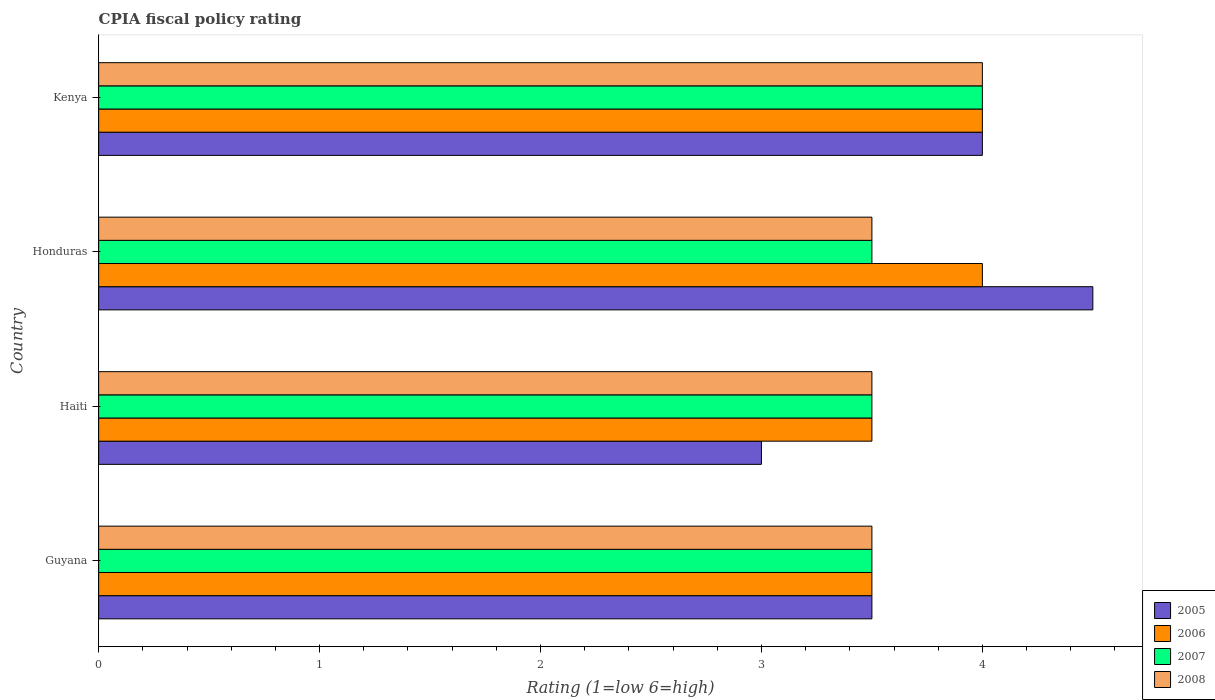How many different coloured bars are there?
Keep it short and to the point. 4. How many groups of bars are there?
Give a very brief answer. 4. Are the number of bars on each tick of the Y-axis equal?
Offer a very short reply. Yes. How many bars are there on the 3rd tick from the bottom?
Provide a succinct answer. 4. What is the label of the 4th group of bars from the top?
Provide a short and direct response. Guyana. In how many cases, is the number of bars for a given country not equal to the number of legend labels?
Provide a short and direct response. 0. What is the CPIA rating in 2008 in Kenya?
Your response must be concise. 4. In which country was the CPIA rating in 2007 maximum?
Make the answer very short. Kenya. In which country was the CPIA rating in 2005 minimum?
Provide a succinct answer. Haiti. What is the difference between the CPIA rating in 2005 in Guyana and that in Haiti?
Your answer should be very brief. 0.5. What is the average CPIA rating in 2008 per country?
Keep it short and to the point. 3.62. What is the difference between the CPIA rating in 2008 and CPIA rating in 2006 in Guyana?
Provide a succinct answer. 0. In how many countries, is the CPIA rating in 2008 greater than 2.4 ?
Give a very brief answer. 4. What is the difference between the highest and the second highest CPIA rating in 2008?
Provide a succinct answer. 0.5. What is the difference between the highest and the lowest CPIA rating in 2005?
Give a very brief answer. 1.5. In how many countries, is the CPIA rating in 2007 greater than the average CPIA rating in 2007 taken over all countries?
Your answer should be very brief. 1. What does the 2nd bar from the top in Haiti represents?
Offer a very short reply. 2007. Is it the case that in every country, the sum of the CPIA rating in 2006 and CPIA rating in 2007 is greater than the CPIA rating in 2005?
Provide a short and direct response. Yes. How many bars are there?
Ensure brevity in your answer.  16. What is the difference between two consecutive major ticks on the X-axis?
Offer a very short reply. 1. Does the graph contain any zero values?
Your answer should be compact. No. Where does the legend appear in the graph?
Provide a succinct answer. Bottom right. How are the legend labels stacked?
Provide a succinct answer. Vertical. What is the title of the graph?
Offer a very short reply. CPIA fiscal policy rating. What is the label or title of the X-axis?
Give a very brief answer. Rating (1=low 6=high). What is the Rating (1=low 6=high) in 2005 in Guyana?
Your answer should be compact. 3.5. What is the Rating (1=low 6=high) in 2006 in Guyana?
Offer a terse response. 3.5. What is the Rating (1=low 6=high) in 2007 in Guyana?
Your answer should be compact. 3.5. What is the Rating (1=low 6=high) of 2006 in Haiti?
Offer a very short reply. 3.5. What is the Rating (1=low 6=high) in 2005 in Honduras?
Offer a very short reply. 4.5. What is the Rating (1=low 6=high) of 2006 in Honduras?
Keep it short and to the point. 4. What is the Rating (1=low 6=high) in 2006 in Kenya?
Make the answer very short. 4. What is the Rating (1=low 6=high) in 2007 in Kenya?
Offer a terse response. 4. Across all countries, what is the maximum Rating (1=low 6=high) of 2005?
Keep it short and to the point. 4.5. Across all countries, what is the minimum Rating (1=low 6=high) in 2005?
Offer a terse response. 3. Across all countries, what is the minimum Rating (1=low 6=high) of 2006?
Make the answer very short. 3.5. Across all countries, what is the minimum Rating (1=low 6=high) in 2008?
Your answer should be compact. 3.5. What is the total Rating (1=low 6=high) in 2006 in the graph?
Provide a short and direct response. 15. What is the total Rating (1=low 6=high) in 2007 in the graph?
Keep it short and to the point. 14.5. What is the difference between the Rating (1=low 6=high) of 2008 in Guyana and that in Haiti?
Provide a short and direct response. 0. What is the difference between the Rating (1=low 6=high) in 2005 in Guyana and that in Honduras?
Your answer should be compact. -1. What is the difference between the Rating (1=low 6=high) in 2008 in Guyana and that in Honduras?
Provide a short and direct response. 0. What is the difference between the Rating (1=low 6=high) of 2005 in Guyana and that in Kenya?
Give a very brief answer. -0.5. What is the difference between the Rating (1=low 6=high) in 2007 in Guyana and that in Kenya?
Your response must be concise. -0.5. What is the difference between the Rating (1=low 6=high) of 2008 in Guyana and that in Kenya?
Keep it short and to the point. -0.5. What is the difference between the Rating (1=low 6=high) of 2006 in Haiti and that in Honduras?
Your answer should be compact. -0.5. What is the difference between the Rating (1=low 6=high) of 2007 in Haiti and that in Honduras?
Give a very brief answer. 0. What is the difference between the Rating (1=low 6=high) of 2008 in Haiti and that in Honduras?
Offer a very short reply. 0. What is the difference between the Rating (1=low 6=high) of 2005 in Haiti and that in Kenya?
Make the answer very short. -1. What is the difference between the Rating (1=low 6=high) of 2006 in Haiti and that in Kenya?
Your answer should be compact. -0.5. What is the difference between the Rating (1=low 6=high) of 2007 in Haiti and that in Kenya?
Give a very brief answer. -0.5. What is the difference between the Rating (1=low 6=high) of 2008 in Haiti and that in Kenya?
Give a very brief answer. -0.5. What is the difference between the Rating (1=low 6=high) of 2005 in Honduras and that in Kenya?
Provide a short and direct response. 0.5. What is the difference between the Rating (1=low 6=high) in 2007 in Honduras and that in Kenya?
Your answer should be very brief. -0.5. What is the difference between the Rating (1=low 6=high) of 2008 in Honduras and that in Kenya?
Make the answer very short. -0.5. What is the difference between the Rating (1=low 6=high) of 2005 in Guyana and the Rating (1=low 6=high) of 2008 in Haiti?
Ensure brevity in your answer.  0. What is the difference between the Rating (1=low 6=high) in 2006 in Guyana and the Rating (1=low 6=high) in 2007 in Haiti?
Offer a very short reply. 0. What is the difference between the Rating (1=low 6=high) in 2006 in Guyana and the Rating (1=low 6=high) in 2008 in Haiti?
Provide a succinct answer. 0. What is the difference between the Rating (1=low 6=high) of 2005 in Guyana and the Rating (1=low 6=high) of 2008 in Honduras?
Ensure brevity in your answer.  0. What is the difference between the Rating (1=low 6=high) in 2007 in Guyana and the Rating (1=low 6=high) in 2008 in Honduras?
Your response must be concise. 0. What is the difference between the Rating (1=low 6=high) of 2005 in Guyana and the Rating (1=low 6=high) of 2006 in Kenya?
Your response must be concise. -0.5. What is the difference between the Rating (1=low 6=high) of 2005 in Guyana and the Rating (1=low 6=high) of 2008 in Kenya?
Offer a terse response. -0.5. What is the difference between the Rating (1=low 6=high) of 2006 in Guyana and the Rating (1=low 6=high) of 2007 in Kenya?
Provide a short and direct response. -0.5. What is the difference between the Rating (1=low 6=high) of 2007 in Guyana and the Rating (1=low 6=high) of 2008 in Kenya?
Provide a short and direct response. -0.5. What is the difference between the Rating (1=low 6=high) in 2005 in Haiti and the Rating (1=low 6=high) in 2007 in Honduras?
Give a very brief answer. -0.5. What is the difference between the Rating (1=low 6=high) in 2005 in Haiti and the Rating (1=low 6=high) in 2006 in Kenya?
Provide a short and direct response. -1. What is the difference between the Rating (1=low 6=high) in 2007 in Haiti and the Rating (1=low 6=high) in 2008 in Kenya?
Offer a terse response. -0.5. What is the difference between the Rating (1=low 6=high) of 2007 in Honduras and the Rating (1=low 6=high) of 2008 in Kenya?
Offer a terse response. -0.5. What is the average Rating (1=low 6=high) in 2005 per country?
Offer a very short reply. 3.75. What is the average Rating (1=low 6=high) in 2006 per country?
Make the answer very short. 3.75. What is the average Rating (1=low 6=high) in 2007 per country?
Your answer should be very brief. 3.62. What is the average Rating (1=low 6=high) in 2008 per country?
Your answer should be very brief. 3.62. What is the difference between the Rating (1=low 6=high) of 2005 and Rating (1=low 6=high) of 2006 in Guyana?
Give a very brief answer. 0. What is the difference between the Rating (1=low 6=high) of 2005 and Rating (1=low 6=high) of 2008 in Guyana?
Make the answer very short. 0. What is the difference between the Rating (1=low 6=high) in 2006 and Rating (1=low 6=high) in 2007 in Guyana?
Give a very brief answer. 0. What is the difference between the Rating (1=low 6=high) of 2006 and Rating (1=low 6=high) of 2007 in Haiti?
Provide a short and direct response. 0. What is the difference between the Rating (1=low 6=high) in 2006 and Rating (1=low 6=high) in 2008 in Haiti?
Provide a short and direct response. 0. What is the difference between the Rating (1=low 6=high) in 2007 and Rating (1=low 6=high) in 2008 in Haiti?
Your answer should be very brief. 0. What is the difference between the Rating (1=low 6=high) of 2005 and Rating (1=low 6=high) of 2008 in Honduras?
Offer a terse response. 1. What is the difference between the Rating (1=low 6=high) in 2006 and Rating (1=low 6=high) in 2007 in Honduras?
Offer a terse response. 0.5. What is the difference between the Rating (1=low 6=high) in 2005 and Rating (1=low 6=high) in 2006 in Kenya?
Provide a short and direct response. 0. What is the difference between the Rating (1=low 6=high) in 2005 and Rating (1=low 6=high) in 2008 in Kenya?
Offer a terse response. 0. What is the difference between the Rating (1=low 6=high) of 2007 and Rating (1=low 6=high) of 2008 in Kenya?
Offer a very short reply. 0. What is the ratio of the Rating (1=low 6=high) in 2008 in Guyana to that in Haiti?
Provide a succinct answer. 1. What is the ratio of the Rating (1=low 6=high) in 2005 in Guyana to that in Honduras?
Your answer should be very brief. 0.78. What is the ratio of the Rating (1=low 6=high) in 2006 in Guyana to that in Honduras?
Offer a very short reply. 0.88. What is the ratio of the Rating (1=low 6=high) in 2007 in Guyana to that in Kenya?
Your answer should be compact. 0.88. What is the ratio of the Rating (1=low 6=high) of 2008 in Guyana to that in Kenya?
Offer a terse response. 0.88. What is the ratio of the Rating (1=low 6=high) of 2007 in Haiti to that in Honduras?
Provide a succinct answer. 1. What is the ratio of the Rating (1=low 6=high) of 2008 in Haiti to that in Honduras?
Give a very brief answer. 1. What is the ratio of the Rating (1=low 6=high) of 2005 in Haiti to that in Kenya?
Your answer should be compact. 0.75. What is the ratio of the Rating (1=low 6=high) of 2007 in Haiti to that in Kenya?
Offer a very short reply. 0.88. What is the ratio of the Rating (1=low 6=high) in 2005 in Honduras to that in Kenya?
Ensure brevity in your answer.  1.12. What is the ratio of the Rating (1=low 6=high) of 2006 in Honduras to that in Kenya?
Your answer should be very brief. 1. What is the difference between the highest and the second highest Rating (1=low 6=high) of 2006?
Make the answer very short. 0. What is the difference between the highest and the second highest Rating (1=low 6=high) in 2007?
Make the answer very short. 0.5. What is the difference between the highest and the lowest Rating (1=low 6=high) of 2005?
Give a very brief answer. 1.5. What is the difference between the highest and the lowest Rating (1=low 6=high) of 2007?
Provide a short and direct response. 0.5. 